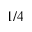<formula> <loc_0><loc_0><loc_500><loc_500>1 / 4</formula> 